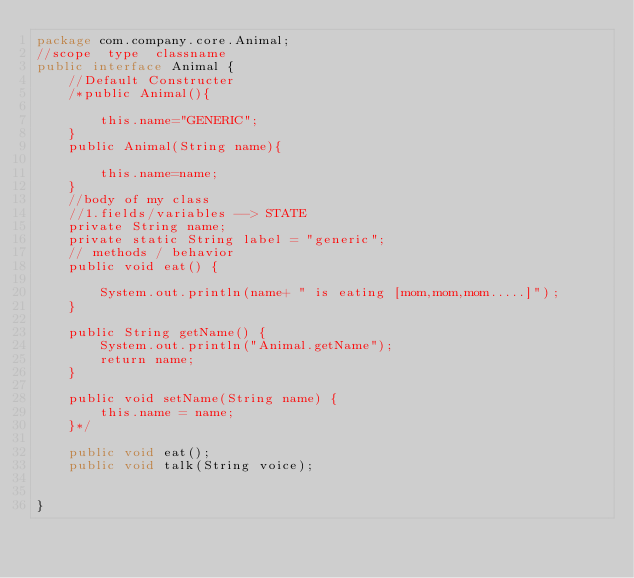Convert code to text. <code><loc_0><loc_0><loc_500><loc_500><_Java_>package com.company.core.Animal;
//scope  type  classname
public interface Animal {
    //Default Constructer
    /*public Animal(){

        this.name="GENERIC";
    }
    public Animal(String name){

        this.name=name;
    }
    //body of my class
    //1.fields/variables --> STATE
    private String name;
    private static String label = "generic";
    // methods / behavior
    public void eat() {

        System.out.println(name+ " is eating [mom,mom,mom.....]");
    }

    public String getName() {
        System.out.println("Animal.getName");
        return name;
    }

    public void setName(String name) {
        this.name = name;
    }*/

    public void eat();
    public void talk(String voice);


}
</code> 